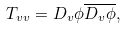Convert formula to latex. <formula><loc_0><loc_0><loc_500><loc_500>T _ { v v } = D _ { v } \phi \overline { D _ { v } { \phi } } ,</formula> 